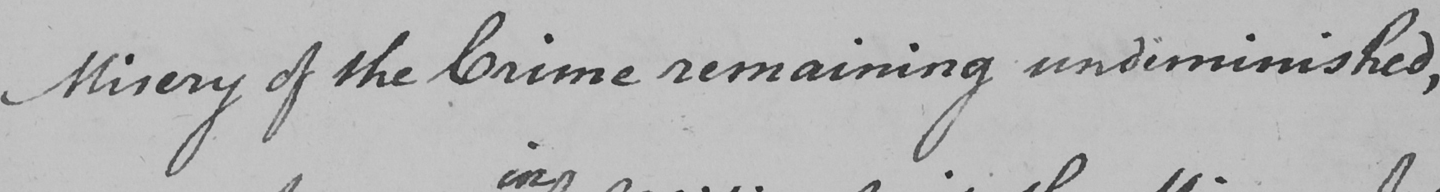What text is written in this handwritten line? Misery of the Crime remaining undiminished , 